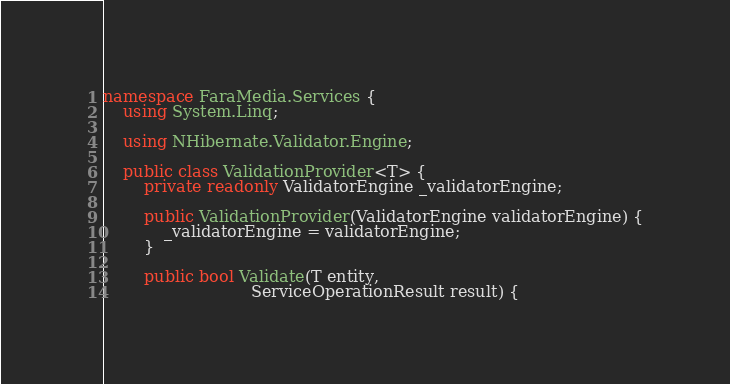Convert code to text. <code><loc_0><loc_0><loc_500><loc_500><_C#_>namespace FaraMedia.Services {
	using System.Linq;

	using NHibernate.Validator.Engine;

	public class ValidationProvider<T> {
		private readonly ValidatorEngine _validatorEngine;

		public ValidationProvider(ValidatorEngine validatorEngine) {
			_validatorEngine = validatorEngine;
		}

		public bool Validate(T entity,
		                     ServiceOperationResult result) {</code> 